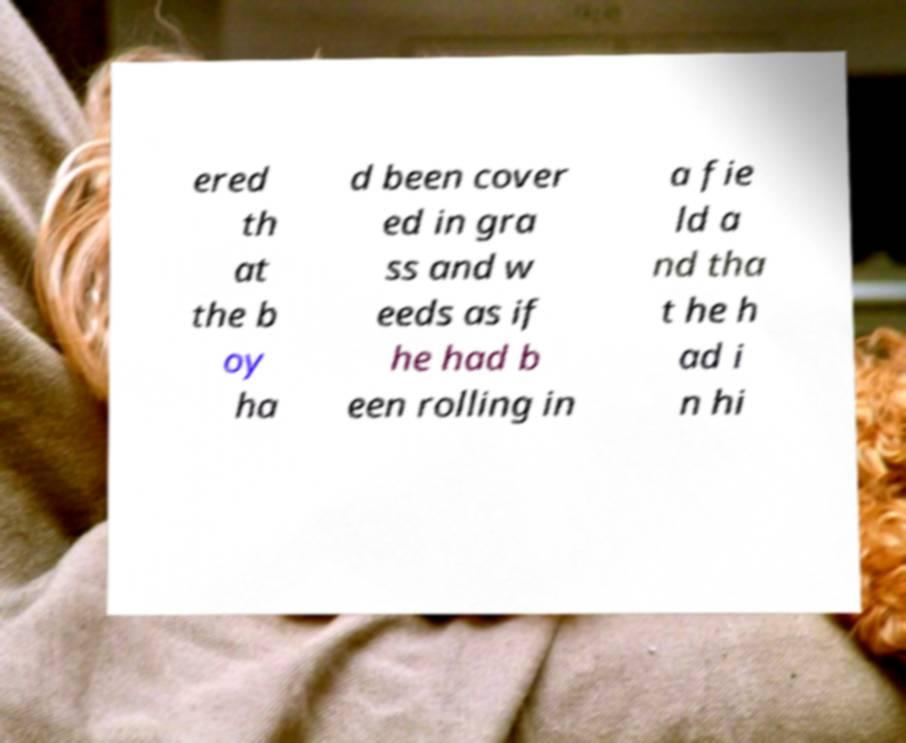Can you read and provide the text displayed in the image?This photo seems to have some interesting text. Can you extract and type it out for me? ered th at the b oy ha d been cover ed in gra ss and w eeds as if he had b een rolling in a fie ld a nd tha t he h ad i n hi 